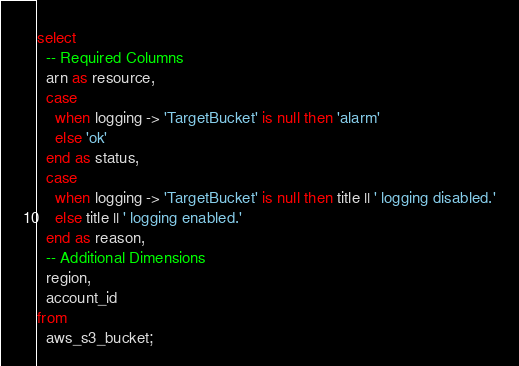Convert code to text. <code><loc_0><loc_0><loc_500><loc_500><_SQL_>select
  -- Required Columns
  arn as resource,
  case
    when logging -> 'TargetBucket' is null then 'alarm'
    else 'ok'
  end as status,
  case
    when logging -> 'TargetBucket' is null then title || ' logging disabled.'
    else title || ' logging enabled.'
  end as reason,
  -- Additional Dimensions
  region,
  account_id
from
  aws_s3_bucket;</code> 